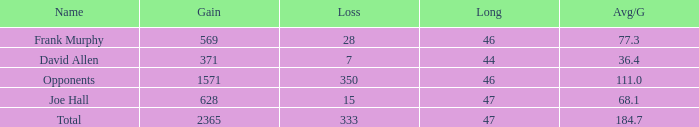How much Avg/G has a Gain smaller than 1571, and a Long smaller than 46? 1.0. 